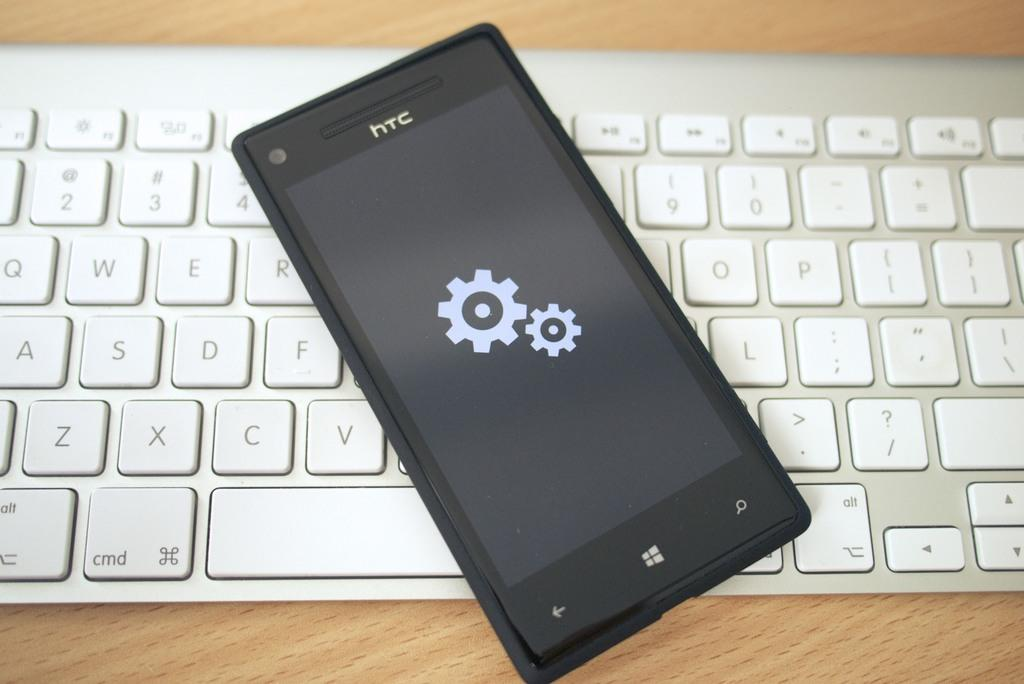<image>
Render a clear and concise summary of the photo. Black HTC cellphone on top of a white keyboard. 